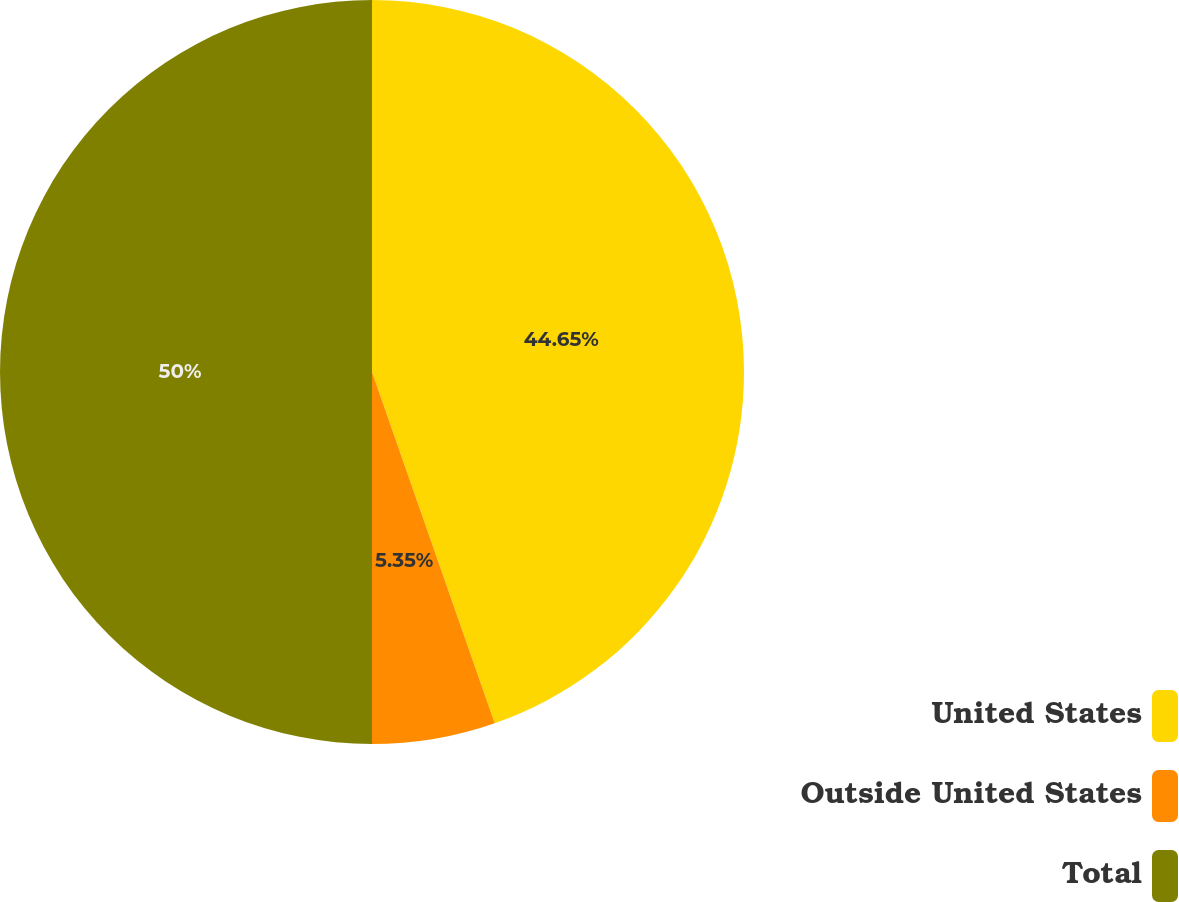Convert chart. <chart><loc_0><loc_0><loc_500><loc_500><pie_chart><fcel>United States<fcel>Outside United States<fcel>Total<nl><fcel>44.65%<fcel>5.35%<fcel>50.0%<nl></chart> 